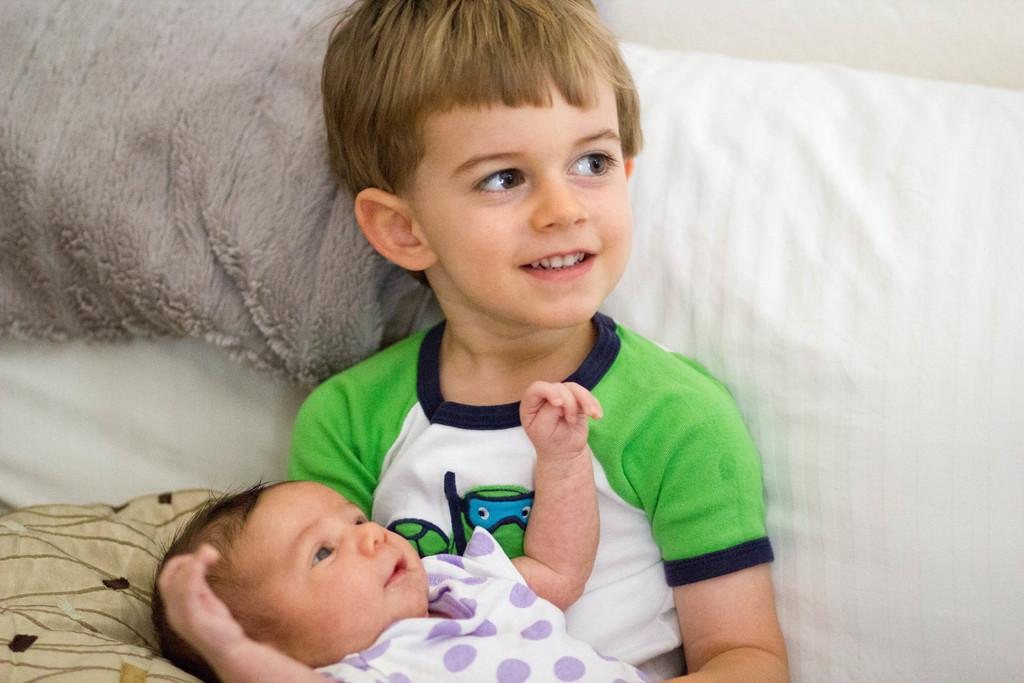Who is present in the image? There is a boy and a baby in the image. What is the boy wearing? The boy is wearing a green t-shirt. What is the baby wearing? The baby is wearing a white dress. What is the boy's facial expression? The boy has a smile on his face. What type of division is being performed by the brass instrument in the image? There is no brass instrument or division being performed in the image; it features a boy and a baby. What knowledge can be gained from the baby's facial expression in the image? The baby's facial expression cannot be seen in the image, as it only shows the boy's facial expression. 